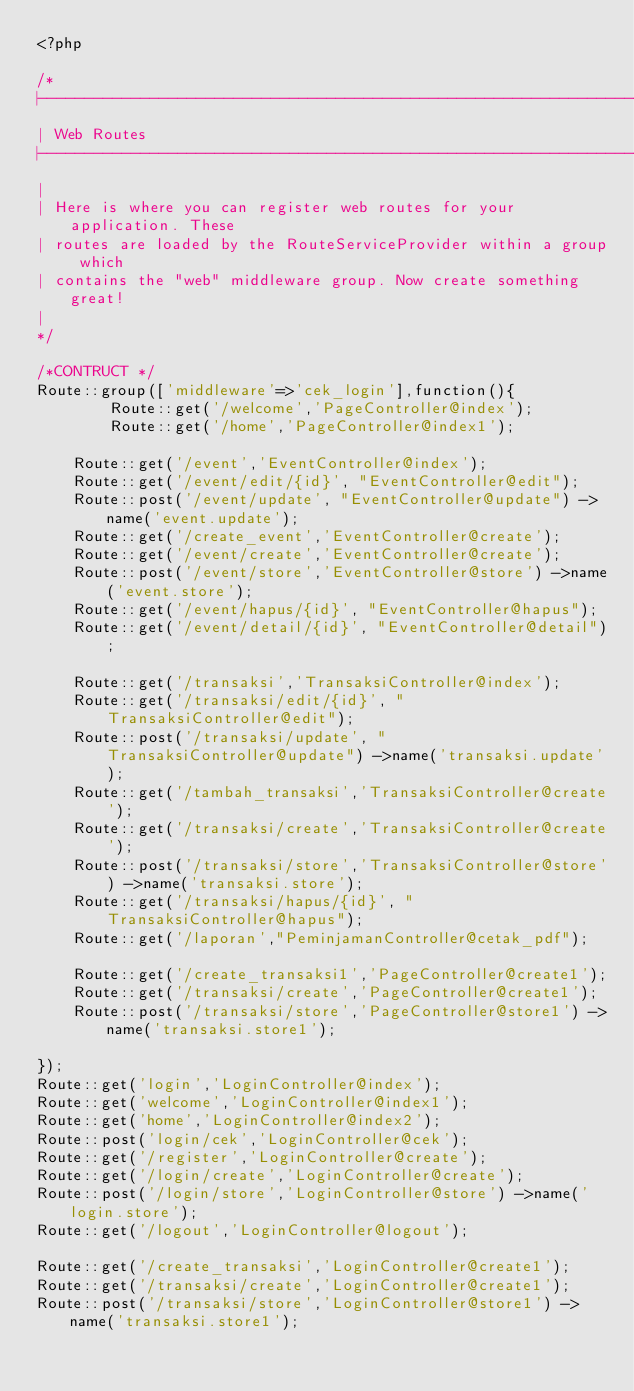Convert code to text. <code><loc_0><loc_0><loc_500><loc_500><_PHP_><?php

/*
|--------------------------------------------------------------------------
| Web Routes
|--------------------------------------------------------------------------
|
| Here is where you can register web routes for your application. These
| routes are loaded by the RouteServiceProvider within a group which
| contains the "web" middleware group. Now create something great!
|
*/

/*CONTRUCT */
Route::group(['middleware'=>'cek_login'],function(){
        Route::get('/welcome','PageController@index');
        Route::get('/home','PageController@index1'); 

    Route::get('/event','EventController@index');
    Route::get('/event/edit/{id}', "EventController@edit");
    Route::post('/event/update', "EventController@update") ->name('event.update');
    Route::get('/create_event','EventController@create');
    Route::get('/event/create','EventController@create');
    Route::post('/event/store','EventController@store') ->name('event.store');
    Route::get('/event/hapus/{id}', "EventController@hapus");
    Route::get('/event/detail/{id}', "EventController@detail");
    
    Route::get('/transaksi','TransaksiController@index');
    Route::get('/transaksi/edit/{id}', "TransaksiController@edit");
    Route::post('/transaksi/update', "TransaksiController@update") ->name('transaksi.update');
    Route::get('/tambah_transaksi','TransaksiController@create');
    Route::get('/transaksi/create','TransaksiController@create');
    Route::post('/transaksi/store','TransaksiController@store') ->name('transaksi.store');
    Route::get('/transaksi/hapus/{id}', "TransaksiController@hapus");
    Route::get('/laporan',"PeminjamanController@cetak_pdf");

    Route::get('/create_transaksi1','PageController@create1');
    Route::get('/transaksi/create','PageController@create1');
    Route::post('/transaksi/store','PageController@store1') ->name('transaksi.store1');

});
Route::get('login','LoginController@index');
Route::get('welcome','LoginController@index1');
Route::get('home','LoginController@index2');
Route::post('login/cek','LoginController@cek');
Route::get('/register','LoginController@create');
Route::get('/login/create','LoginController@create');
Route::post('/login/store','LoginController@store') ->name('login.store');
Route::get('/logout','LoginController@logout');

Route::get('/create_transaksi','LoginController@create1');
Route::get('/transaksi/create','LoginController@create1');
Route::post('/transaksi/store','LoginController@store1') ->name('transaksi.store1');







</code> 